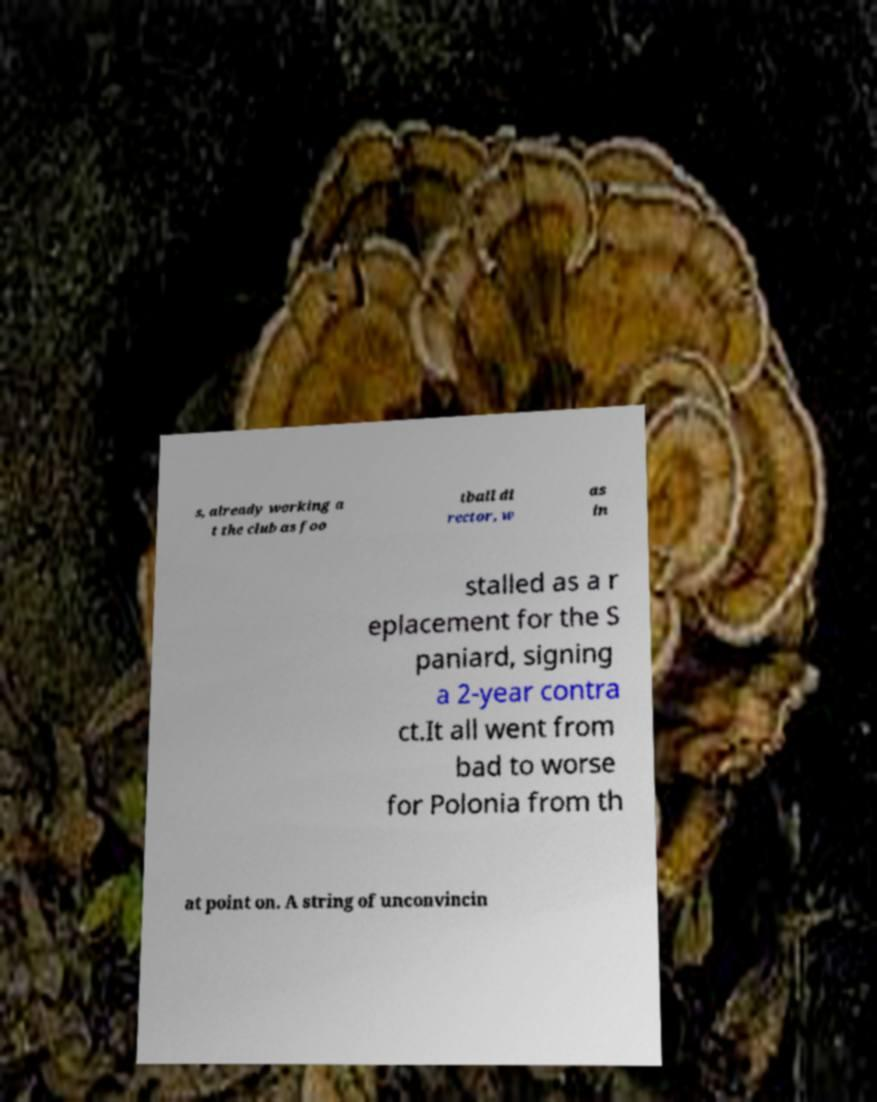Please read and relay the text visible in this image. What does it say? s, already working a t the club as foo tball di rector, w as in stalled as a r eplacement for the S paniard, signing a 2-year contra ct.It all went from bad to worse for Polonia from th at point on. A string of unconvincin 